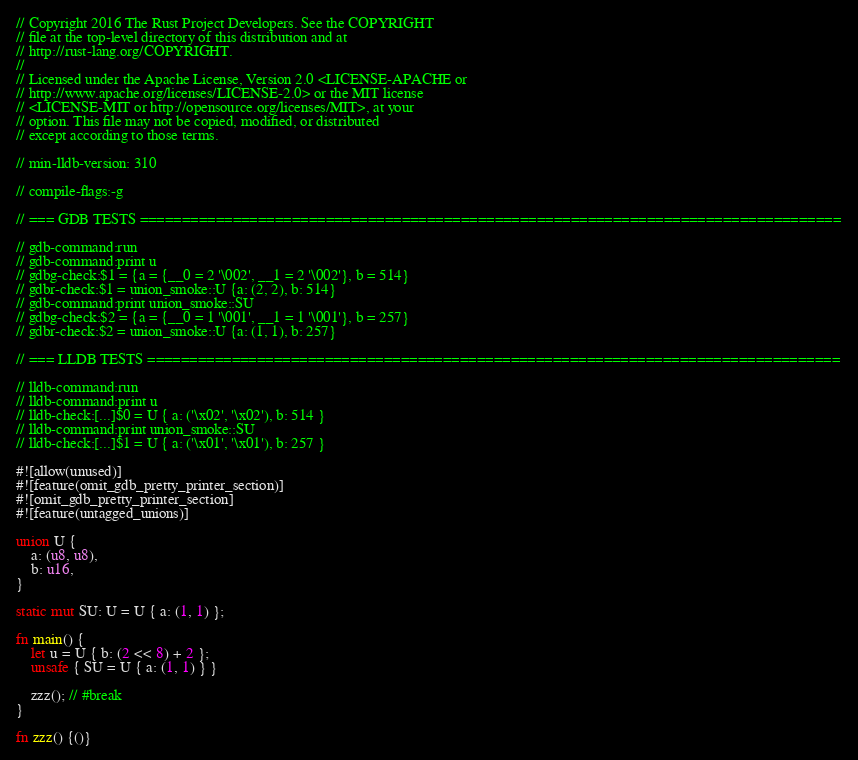<code> <loc_0><loc_0><loc_500><loc_500><_Rust_>// Copyright 2016 The Rust Project Developers. See the COPYRIGHT
// file at the top-level directory of this distribution and at
// http://rust-lang.org/COPYRIGHT.
//
// Licensed under the Apache License, Version 2.0 <LICENSE-APACHE or
// http://www.apache.org/licenses/LICENSE-2.0> or the MIT license
// <LICENSE-MIT or http://opensource.org/licenses/MIT>, at your
// option. This file may not be copied, modified, or distributed
// except according to those terms.

// min-lldb-version: 310

// compile-flags:-g

// === GDB TESTS ===================================================================================

// gdb-command:run
// gdb-command:print u
// gdbg-check:$1 = {a = {__0 = 2 '\002', __1 = 2 '\002'}, b = 514}
// gdbr-check:$1 = union_smoke::U {a: (2, 2), b: 514}
// gdb-command:print union_smoke::SU
// gdbg-check:$2 = {a = {__0 = 1 '\001', __1 = 1 '\001'}, b = 257}
// gdbr-check:$2 = union_smoke::U {a: (1, 1), b: 257}

// === LLDB TESTS ==================================================================================

// lldb-command:run
// lldb-command:print u
// lldb-check:[...]$0 = U { a: ('\x02', '\x02'), b: 514 }
// lldb-command:print union_smoke::SU
// lldb-check:[...]$1 = U { a: ('\x01', '\x01'), b: 257 }

#![allow(unused)]
#![feature(omit_gdb_pretty_printer_section)]
#![omit_gdb_pretty_printer_section]
#![feature(untagged_unions)]

union U {
    a: (u8, u8),
    b: u16,
}

static mut SU: U = U { a: (1, 1) };

fn main() {
    let u = U { b: (2 << 8) + 2 };
    unsafe { SU = U { a: (1, 1) } }

    zzz(); // #break
}

fn zzz() {()}
</code> 